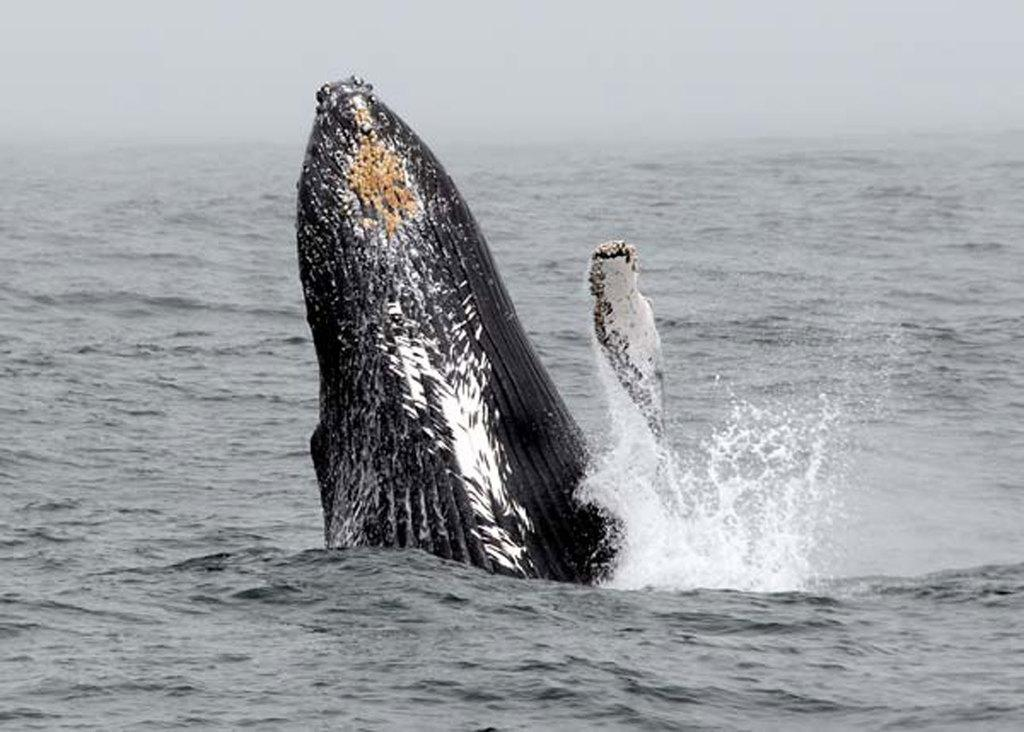What is in the water in the image? There is an animal in the water in the image. What can be seen in the background of the image? The sky is visible in the background of the image. What type of dinosaur can be seen flying in the sky in the image? There are no dinosaurs present in the image, and no dinosaurs can fly. 